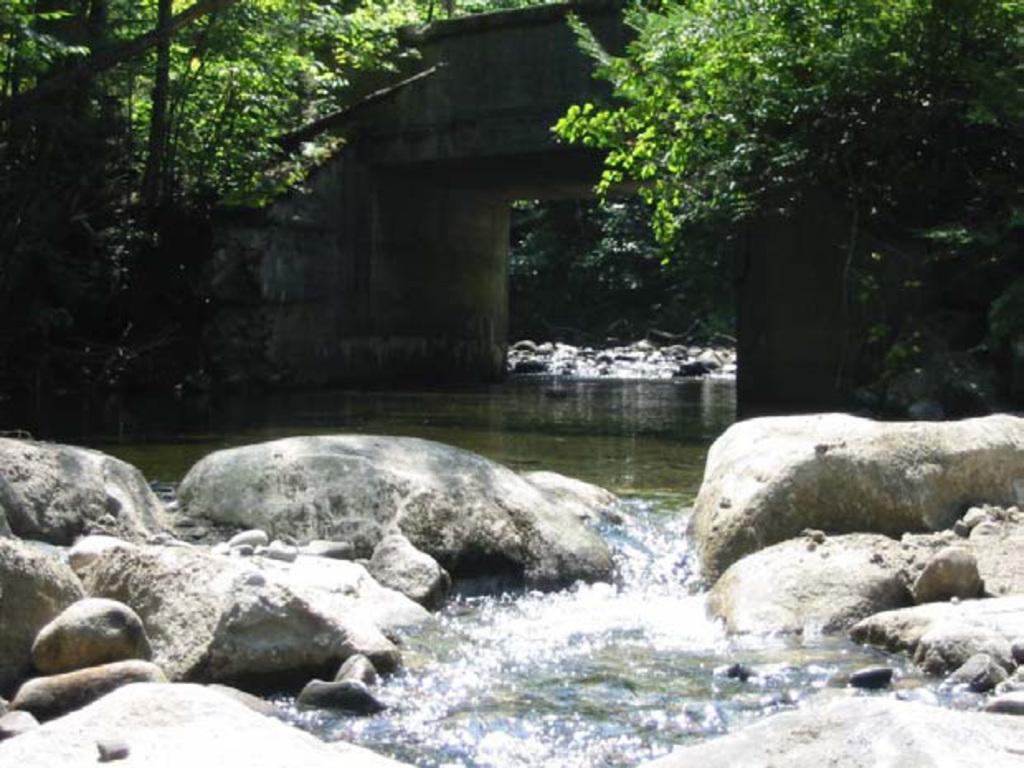Could you give a brief overview of what you see in this image? In this picture I can see rocks and water. In the background I can see trees and a bridge. 